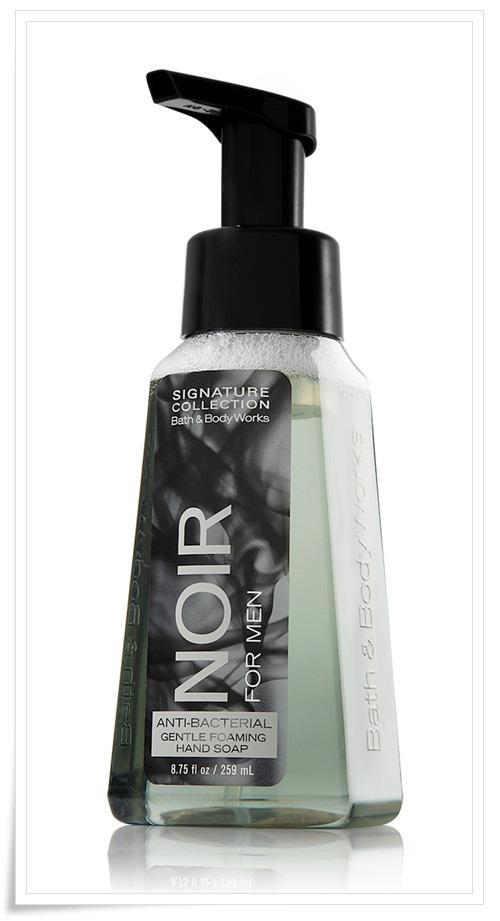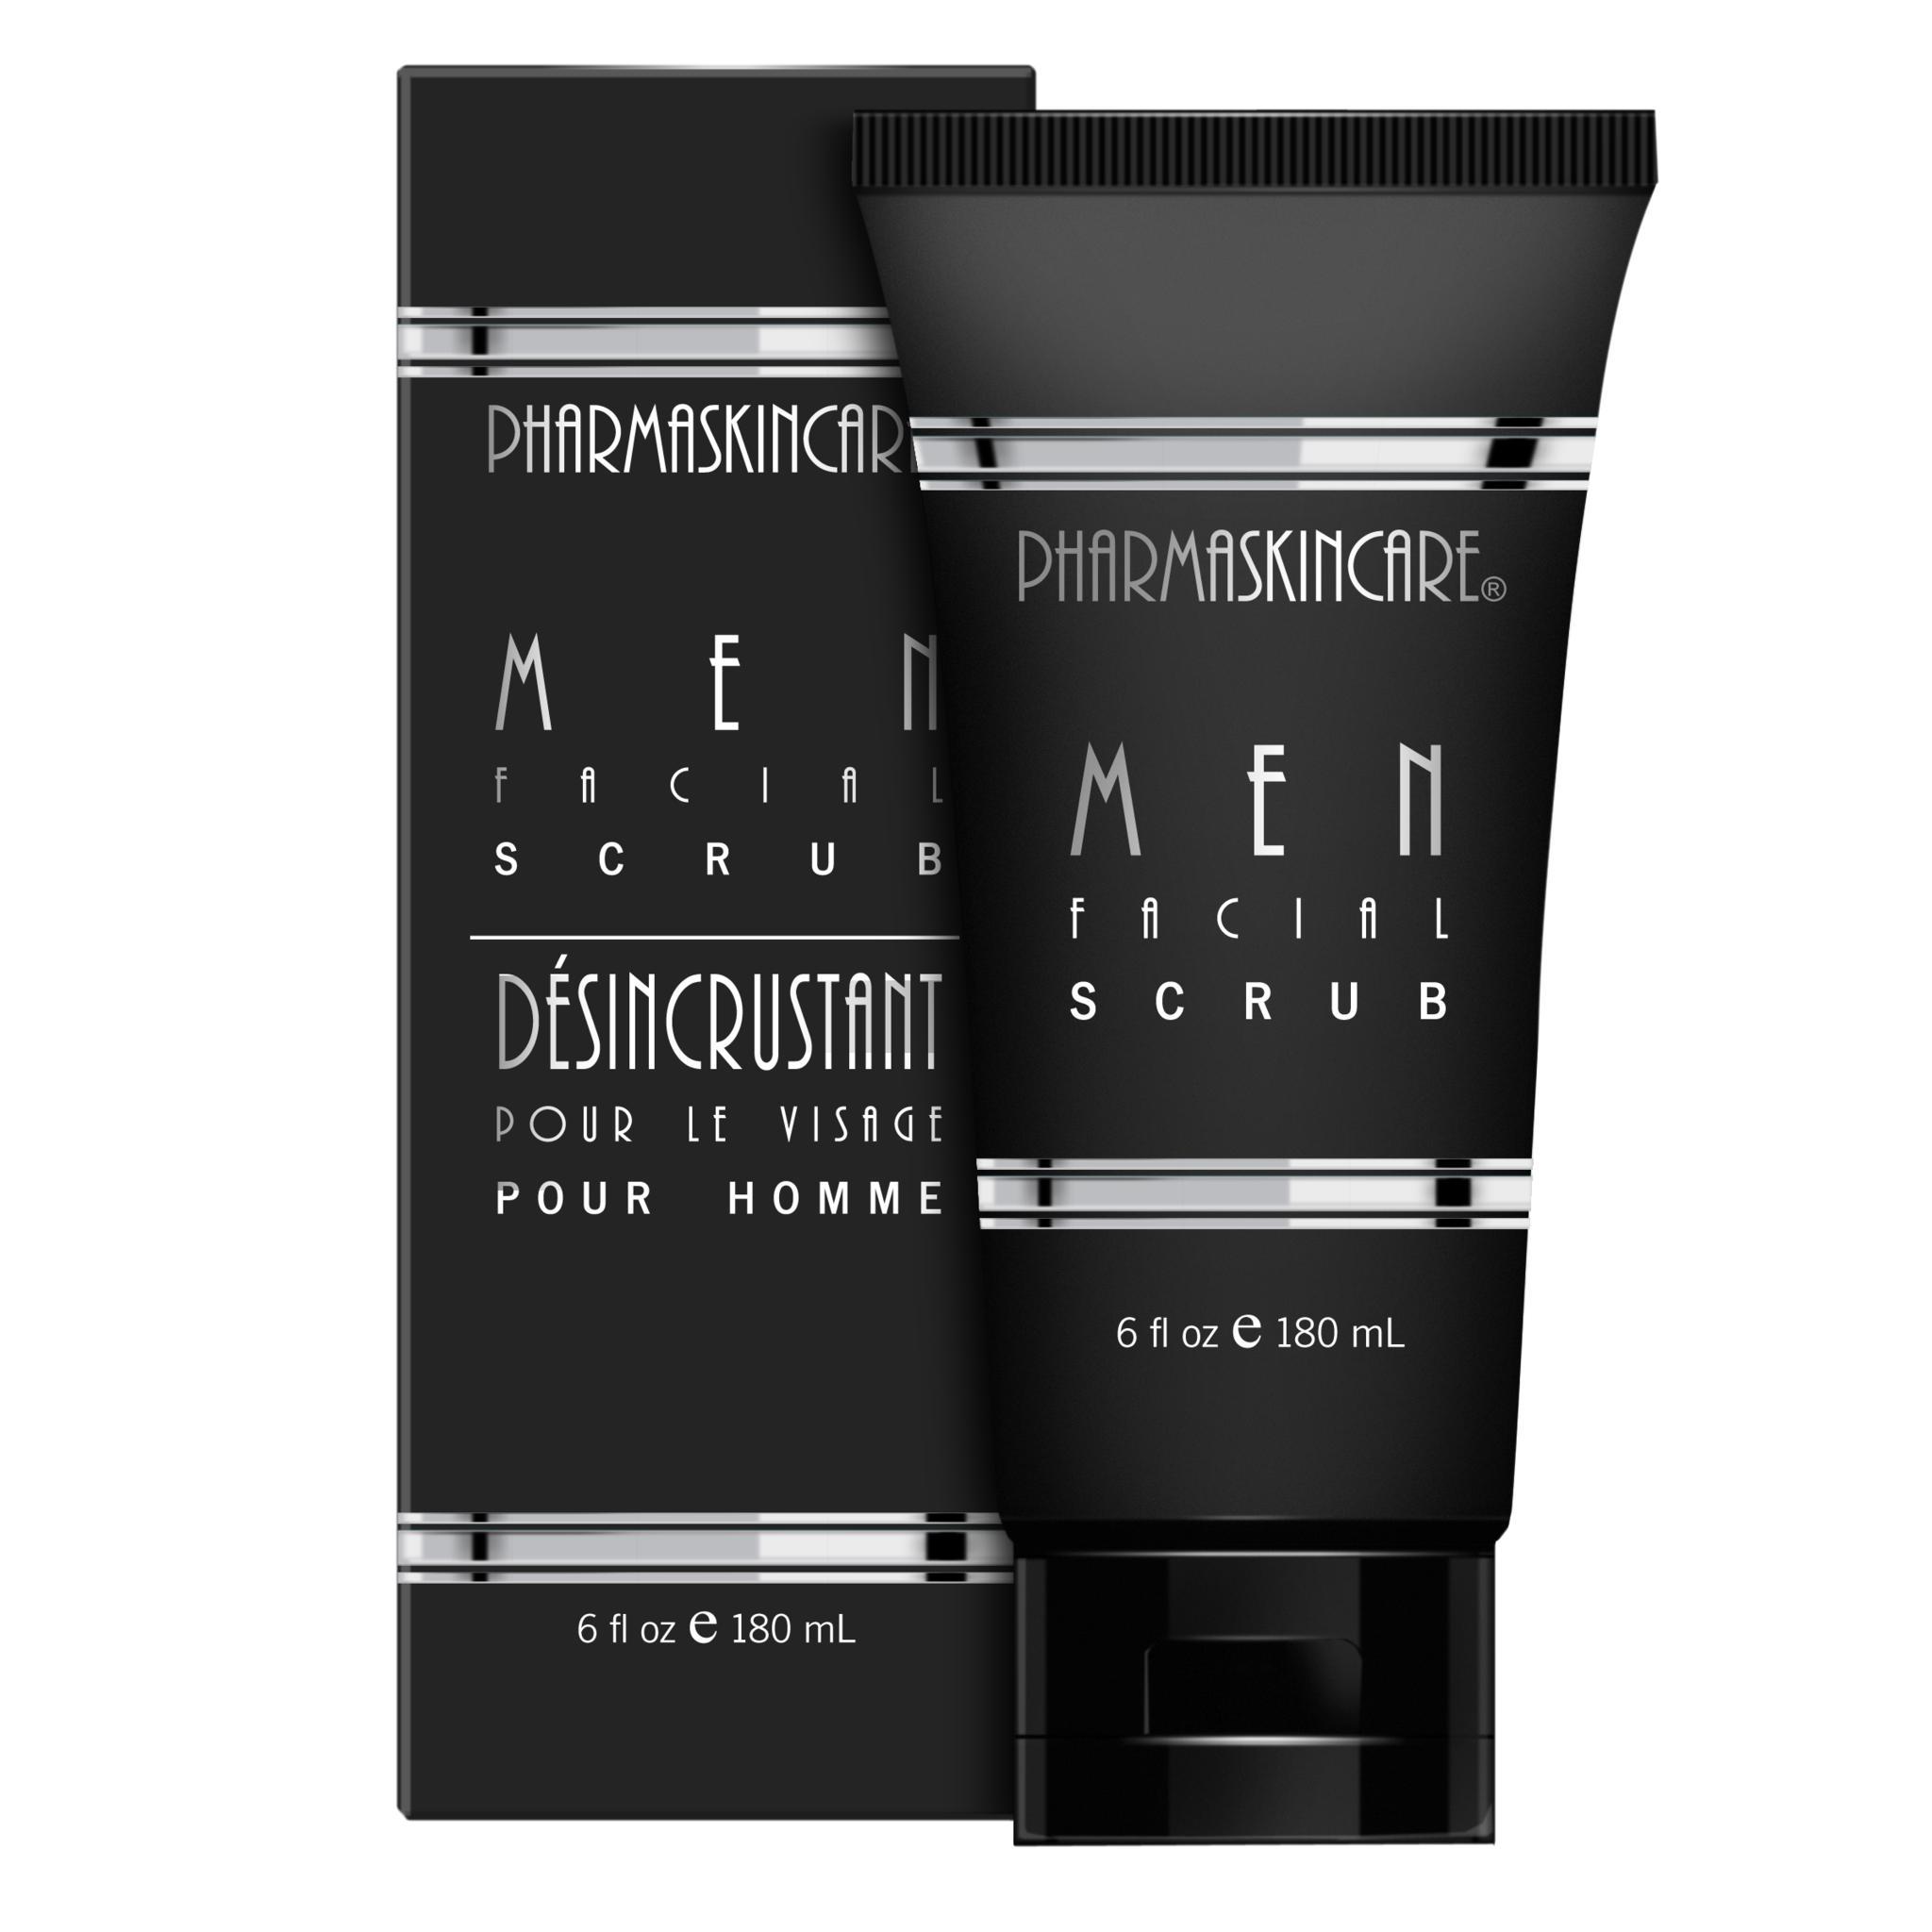The first image is the image on the left, the second image is the image on the right. Evaluate the accuracy of this statement regarding the images: "There are two bottles, both with black caps and white content.". Is it true? Answer yes or no. No. The first image is the image on the left, the second image is the image on the right. Considering the images on both sides, is "An image features one product that stands on its black cap." valid? Answer yes or no. Yes. 